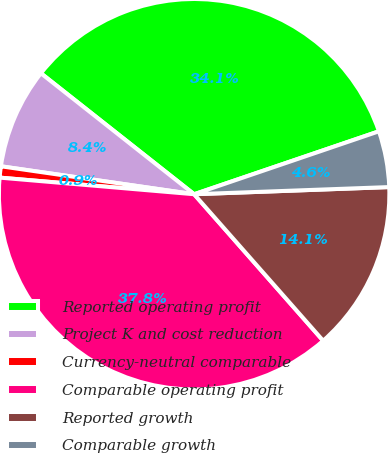Convert chart to OTSL. <chart><loc_0><loc_0><loc_500><loc_500><pie_chart><fcel>Reported operating profit<fcel>Project K and cost reduction<fcel>Currency-neutral comparable<fcel>Comparable operating profit<fcel>Reported growth<fcel>Comparable growth<nl><fcel>34.14%<fcel>8.35%<fcel>0.93%<fcel>37.85%<fcel>14.09%<fcel>4.64%<nl></chart> 